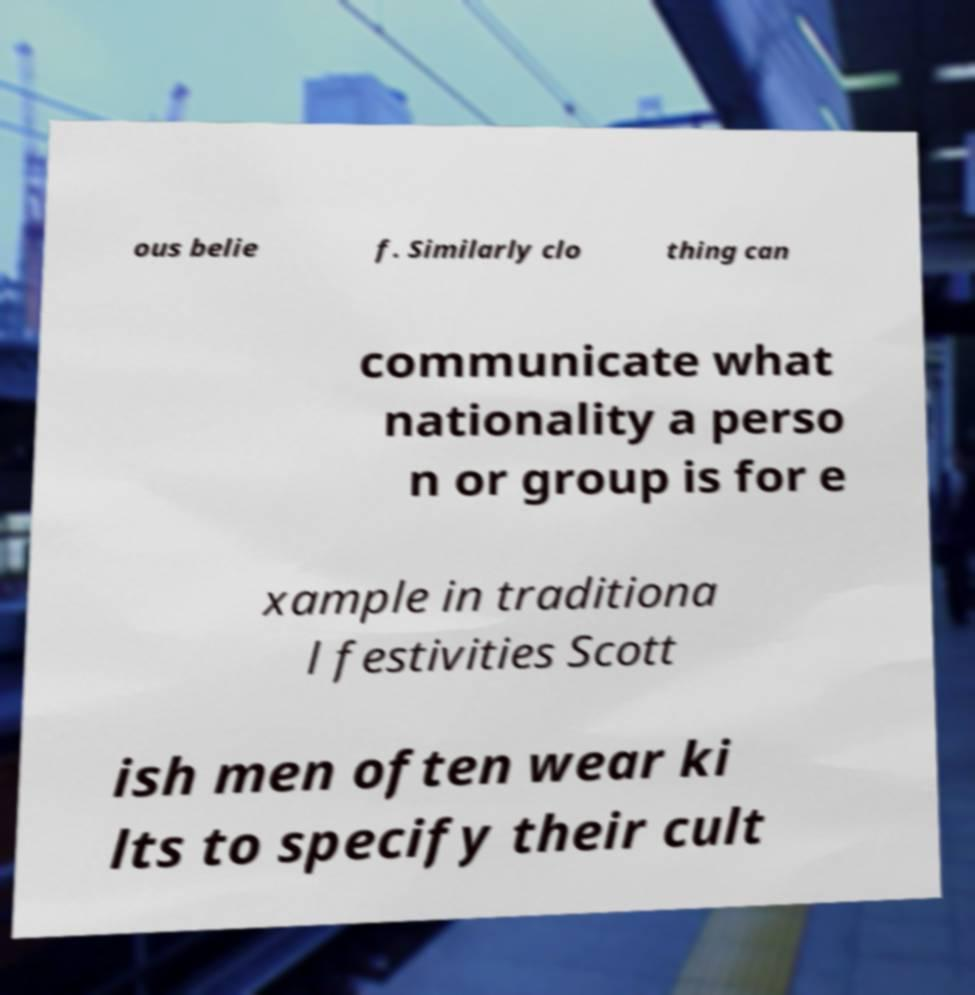Can you accurately transcribe the text from the provided image for me? ous belie f. Similarly clo thing can communicate what nationality a perso n or group is for e xample in traditiona l festivities Scott ish men often wear ki lts to specify their cult 